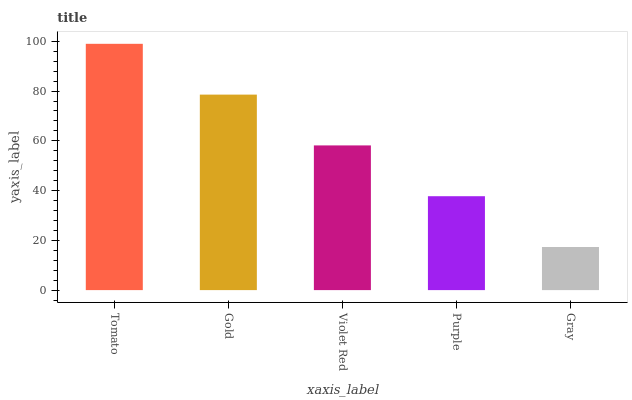Is Gray the minimum?
Answer yes or no. Yes. Is Tomato the maximum?
Answer yes or no. Yes. Is Gold the minimum?
Answer yes or no. No. Is Gold the maximum?
Answer yes or no. No. Is Tomato greater than Gold?
Answer yes or no. Yes. Is Gold less than Tomato?
Answer yes or no. Yes. Is Gold greater than Tomato?
Answer yes or no. No. Is Tomato less than Gold?
Answer yes or no. No. Is Violet Red the high median?
Answer yes or no. Yes. Is Violet Red the low median?
Answer yes or no. Yes. Is Gray the high median?
Answer yes or no. No. Is Gray the low median?
Answer yes or no. No. 